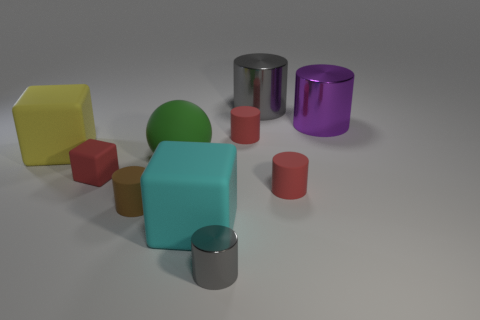What shapes are visible in the image and what colors are they? In the image, you can see various geometric shapes. There's a yellow hexahedron, a green sphere, a turquoise cube, several cylinders in red, silver, and violet, and smaller cubes in red. 